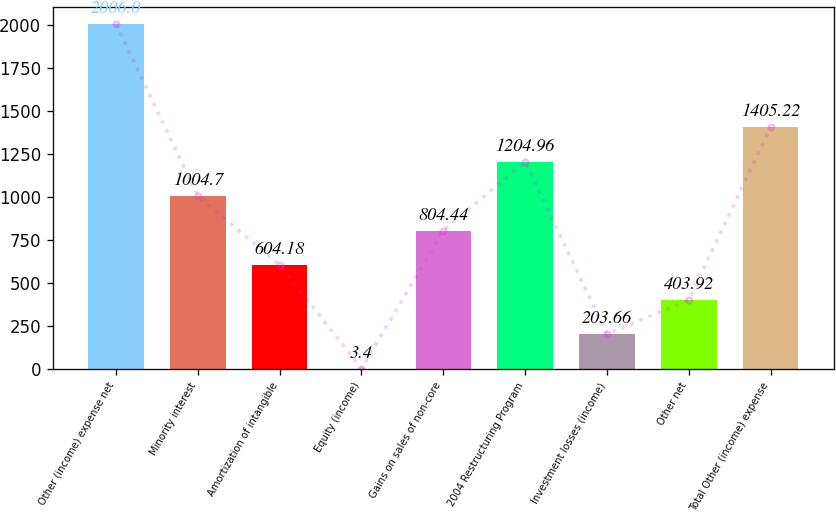Convert chart to OTSL. <chart><loc_0><loc_0><loc_500><loc_500><bar_chart><fcel>Other (income) expense net<fcel>Minority interest<fcel>Amortization of intangible<fcel>Equity (income)<fcel>Gains on sales of non-core<fcel>2004 Restructuring Program<fcel>Investment losses (income)<fcel>Other net<fcel>Total Other (income) expense<nl><fcel>2006<fcel>1004.7<fcel>604.18<fcel>3.4<fcel>804.44<fcel>1204.96<fcel>203.66<fcel>403.92<fcel>1405.22<nl></chart> 